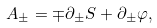Convert formula to latex. <formula><loc_0><loc_0><loc_500><loc_500>A _ { \pm } = \mp \partial _ { \pm } S + \partial _ { \pm } \varphi ,</formula> 